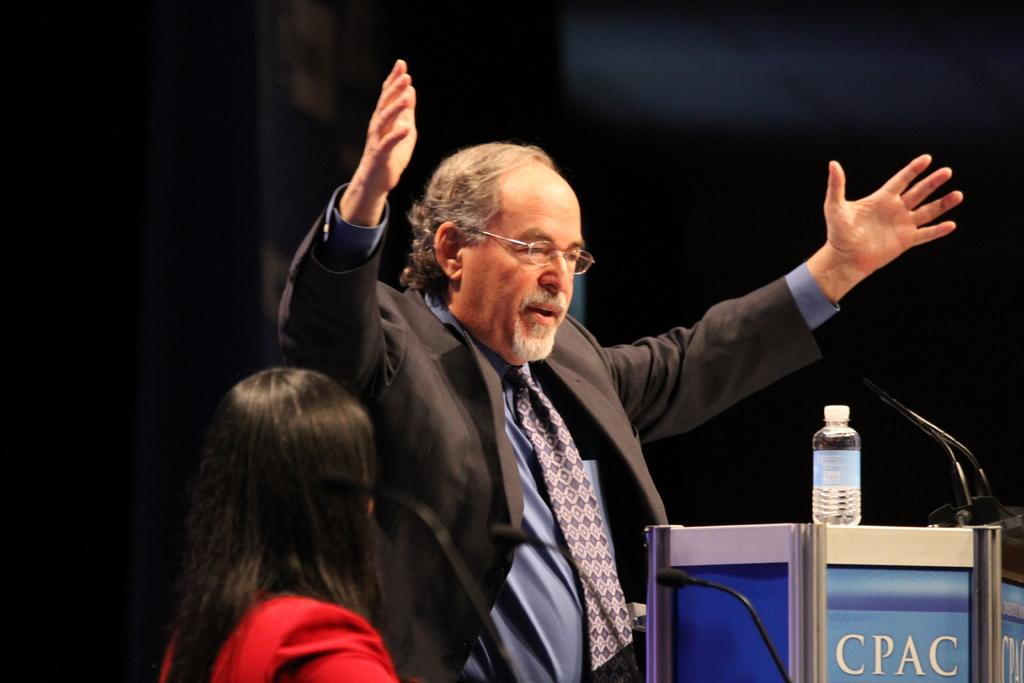<image>
Render a clear and concise summary of the photo. A man holds his hands up in front of a podium that says CPAC> 